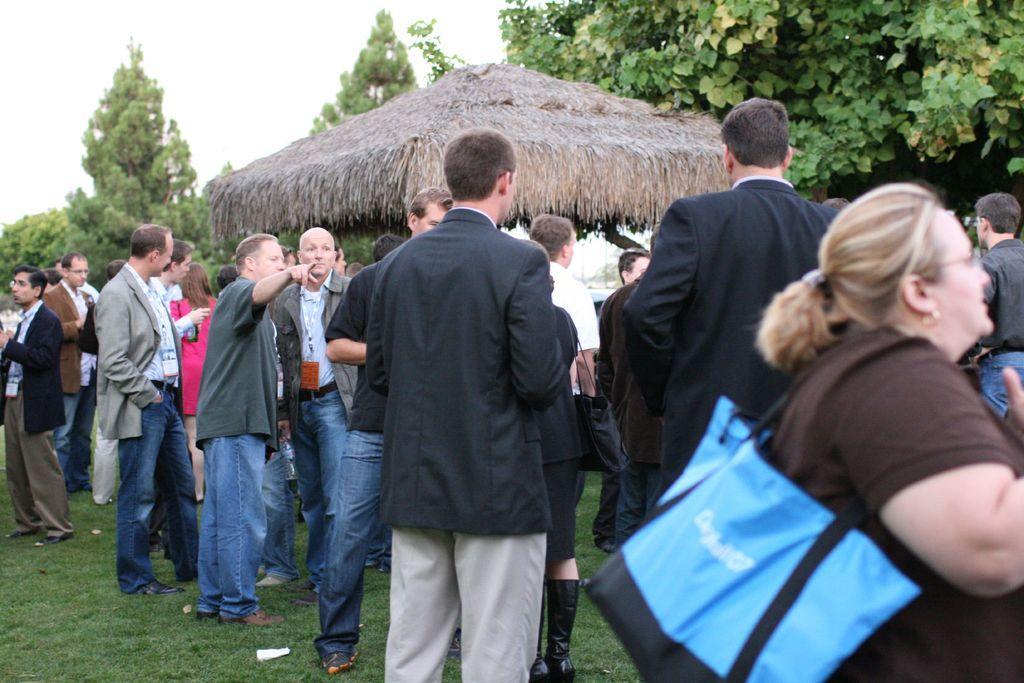Describe this image in one or two sentences. This image is clicked outside. There are trees at the top. There is something like hit in the middle. There are so many people standing in the middle. 